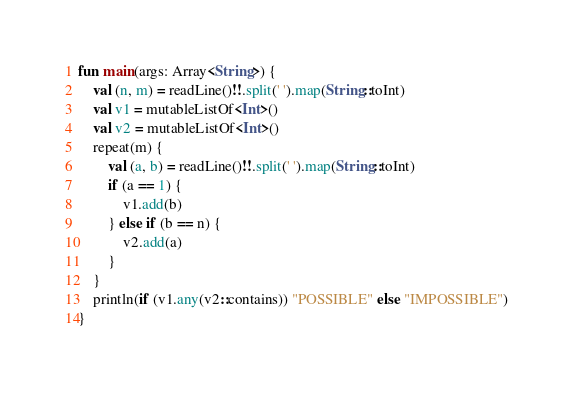Convert code to text. <code><loc_0><loc_0><loc_500><loc_500><_Kotlin_>fun main(args: Array<String>) {
    val (n, m) = readLine()!!.split(' ').map(String::toInt)
    val v1 = mutableListOf<Int>()
    val v2 = mutableListOf<Int>()
    repeat(m) {
        val (a, b) = readLine()!!.split(' ').map(String::toInt)
        if (a == 1) {
            v1.add(b)
        } else if (b == n) {
            v2.add(a)
        }
    }
    println(if (v1.any(v2::contains)) "POSSIBLE" else "IMPOSSIBLE")
}
</code> 